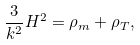Convert formula to latex. <formula><loc_0><loc_0><loc_500><loc_500>\frac { 3 } { k ^ { 2 } } H ^ { 2 } = \rho _ { m } + \rho _ { T } ,</formula> 